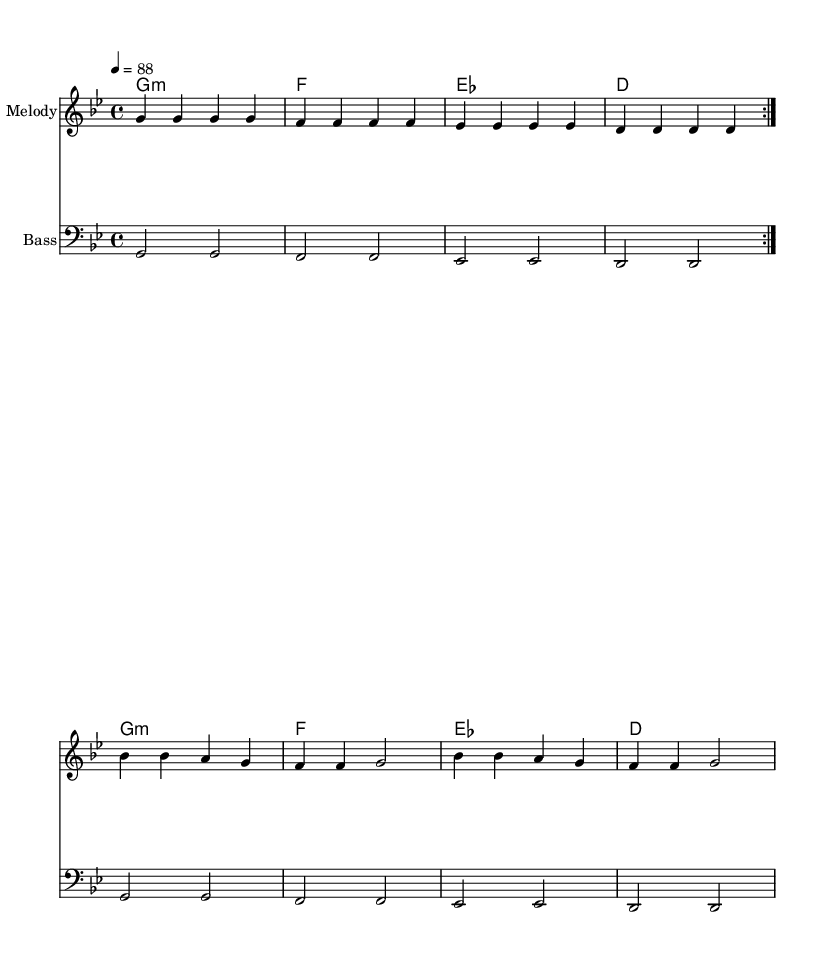What is the key signature of this music? The key signature indicated is G minor, which contains two flats. These flats are B flat and E flat. This can be determined by looking at the key signature notation at the beginning of the sheet music.
Answer: G minor What is the time signature of this music? The time signature indicated is 4/4, meaning there are four beats in a measure and a quarter note gets one beat. This is shown at the beginning of the music staff right after the key signature.
Answer: 4/4 What is the tempo marking in this piece? The tempo marking is indicated as 4 = 88, meaning that there are 88 beats per minute. This notation is typically located at the beginning of the score and gives performers a sense of the speed to play the piece.
Answer: 88 How many measures are in the melody section? The melody section contains eight measures, as seen when counting each grouping separated by vertical lines (bar lines) on the staff. Each sequence of notes between the bar lines counts as one measure.
Answer: 8 What is the chord progression used in this piece? The chord progression used is G minor, F major, E flat major, and D major. This can be identified by looking at the chord symbols written above the melody throughout the piece, where each chord corresponds to the measures of music.
Answer: G minor, F, E flat, D What is the bass clef indicating? The bass clef indicates that the notes are meant to be played in a lower range, suitable for bass instruments. The bass line shown is played on the bass staff, which denotes deeper pitch sounds. This can be seen by noting the clef sign at the beginning of the bass line staff.
Answer: Bass What characterizes the rhythm commonly found in Rhythm and Blues music? Rhythm and Blues often features a strong backbeat, which is a rhythmic emphasis on the second and fourth beats of the measure. This can be perceived in the context of the piece through its driving groove and laid-back feel, particularly in the melodic rhythm and bass part.
Answer: Strong backbeat 